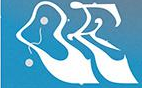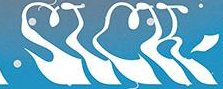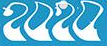Identify the words shown in these images in order, separated by a semicolon. OE; SICK; 2020 